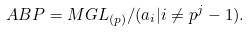Convert formula to latex. <formula><loc_0><loc_0><loc_500><loc_500>A B P = M G L _ { ( p ) } / ( a _ { i } | i \ne p ^ { j } - 1 ) .</formula> 